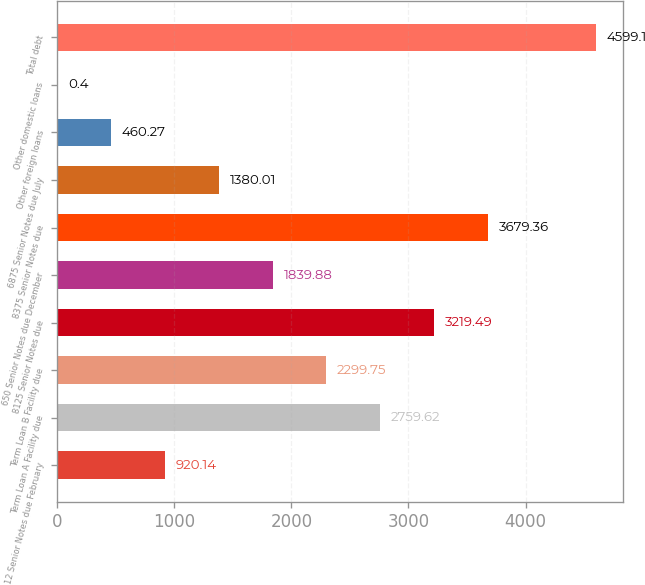Convert chart. <chart><loc_0><loc_0><loc_500><loc_500><bar_chart><fcel>12 Senior Notes due February<fcel>Term Loan A Facility due<fcel>Term Loan B Facility due<fcel>8125 Senior Notes due<fcel>650 Senior Notes due December<fcel>8375 Senior Notes due<fcel>6875 Senior Notes due July<fcel>Other foreign loans<fcel>Other domestic loans<fcel>Total debt<nl><fcel>920.14<fcel>2759.62<fcel>2299.75<fcel>3219.49<fcel>1839.88<fcel>3679.36<fcel>1380.01<fcel>460.27<fcel>0.4<fcel>4599.1<nl></chart> 